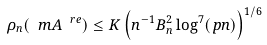Convert formula to latex. <formula><loc_0><loc_0><loc_500><loc_500>\rho _ { n } ( \ m A ^ { \ r e } ) \leq K \left ( n ^ { - 1 } B _ { n } ^ { 2 } \log ^ { 7 } ( p n ) \right ) ^ { 1 / 6 }</formula> 